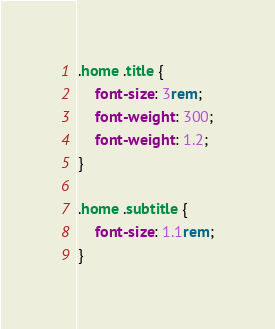<code> <loc_0><loc_0><loc_500><loc_500><_CSS_>.home .title {
    font-size: 3rem;
    font-weight: 300;
    font-weight: 1.2;
}

.home .subtitle {
    font-size: 1.1rem;
}</code> 